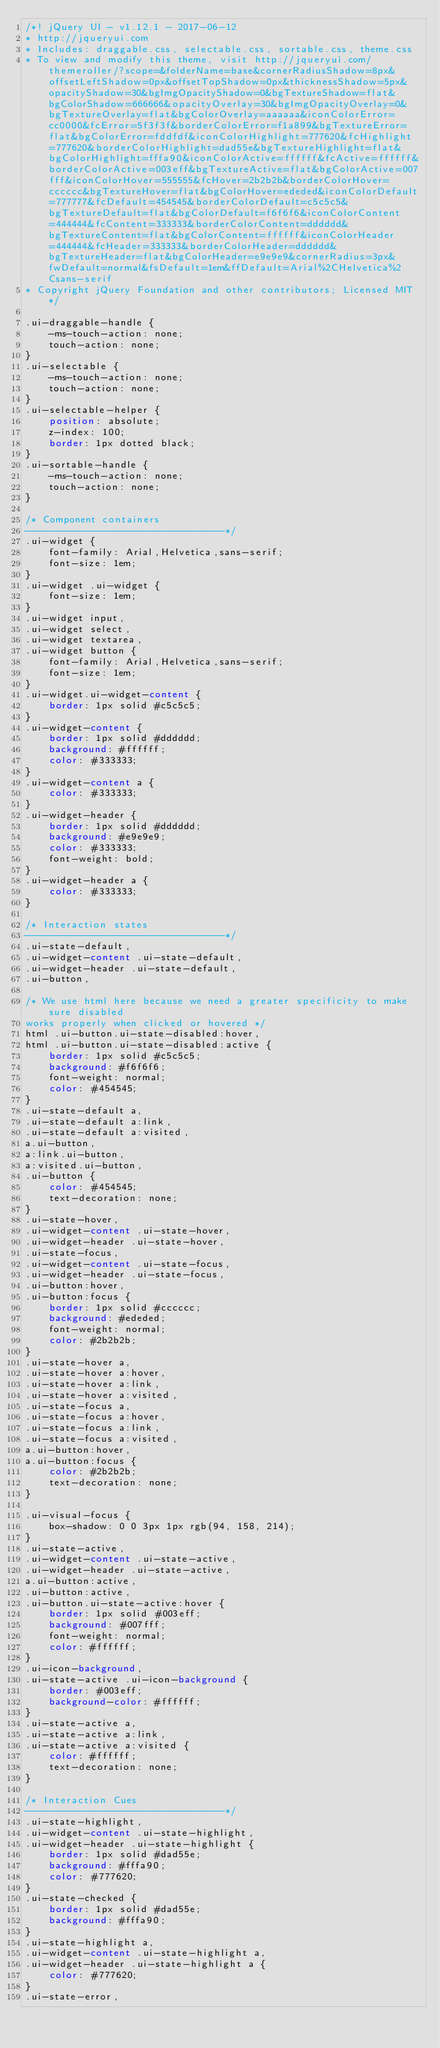<code> <loc_0><loc_0><loc_500><loc_500><_CSS_>/*! jQuery UI - v1.12.1 - 2017-06-12
* http://jqueryui.com
* Includes: draggable.css, selectable.css, sortable.css, theme.css
* To view and modify this theme, visit http://jqueryui.com/themeroller/?scope=&folderName=base&cornerRadiusShadow=8px&offsetLeftShadow=0px&offsetTopShadow=0px&thicknessShadow=5px&opacityShadow=30&bgImgOpacityShadow=0&bgTextureShadow=flat&bgColorShadow=666666&opacityOverlay=30&bgImgOpacityOverlay=0&bgTextureOverlay=flat&bgColorOverlay=aaaaaa&iconColorError=cc0000&fcError=5f3f3f&borderColorError=f1a899&bgTextureError=flat&bgColorError=fddfdf&iconColorHighlight=777620&fcHighlight=777620&borderColorHighlight=dad55e&bgTextureHighlight=flat&bgColorHighlight=fffa90&iconColorActive=ffffff&fcActive=ffffff&borderColorActive=003eff&bgTextureActive=flat&bgColorActive=007fff&iconColorHover=555555&fcHover=2b2b2b&borderColorHover=cccccc&bgTextureHover=flat&bgColorHover=ededed&iconColorDefault=777777&fcDefault=454545&borderColorDefault=c5c5c5&bgTextureDefault=flat&bgColorDefault=f6f6f6&iconColorContent=444444&fcContent=333333&borderColorContent=dddddd&bgTextureContent=flat&bgColorContent=ffffff&iconColorHeader=444444&fcHeader=333333&borderColorHeader=dddddd&bgTextureHeader=flat&bgColorHeader=e9e9e9&cornerRadius=3px&fwDefault=normal&fsDefault=1em&ffDefault=Arial%2CHelvetica%2Csans-serif
* Copyright jQuery Foundation and other contributors; Licensed MIT */

.ui-draggable-handle {
	-ms-touch-action: none;
	touch-action: none;
}
.ui-selectable {
	-ms-touch-action: none;
	touch-action: none;
}
.ui-selectable-helper {
	position: absolute;
	z-index: 100;
	border: 1px dotted black;
}
.ui-sortable-handle {
	-ms-touch-action: none;
	touch-action: none;
}

/* Component containers
----------------------------------*/
.ui-widget {
	font-family: Arial,Helvetica,sans-serif;
	font-size: 1em;
}
.ui-widget .ui-widget {
	font-size: 1em;
}
.ui-widget input,
.ui-widget select,
.ui-widget textarea,
.ui-widget button {
	font-family: Arial,Helvetica,sans-serif;
	font-size: 1em;
}
.ui-widget.ui-widget-content {
	border: 1px solid #c5c5c5;
}
.ui-widget-content {
	border: 1px solid #dddddd;
	background: #ffffff;
	color: #333333;
}
.ui-widget-content a {
	color: #333333;
}
.ui-widget-header {
	border: 1px solid #dddddd;
	background: #e9e9e9;
	color: #333333;
	font-weight: bold;
}
.ui-widget-header a {
	color: #333333;
}

/* Interaction states
----------------------------------*/
.ui-state-default,
.ui-widget-content .ui-state-default,
.ui-widget-header .ui-state-default,
.ui-button,

/* We use html here because we need a greater specificity to make sure disabled
works properly when clicked or hovered */
html .ui-button.ui-state-disabled:hover,
html .ui-button.ui-state-disabled:active {
	border: 1px solid #c5c5c5;
	background: #f6f6f6;
	font-weight: normal;
	color: #454545;
}
.ui-state-default a,
.ui-state-default a:link,
.ui-state-default a:visited,
a.ui-button,
a:link.ui-button,
a:visited.ui-button,
.ui-button {
	color: #454545;
	text-decoration: none;
}
.ui-state-hover,
.ui-widget-content .ui-state-hover,
.ui-widget-header .ui-state-hover,
.ui-state-focus,
.ui-widget-content .ui-state-focus,
.ui-widget-header .ui-state-focus,
.ui-button:hover,
.ui-button:focus {
	border: 1px solid #cccccc;
	background: #ededed;
	font-weight: normal;
	color: #2b2b2b;
}
.ui-state-hover a,
.ui-state-hover a:hover,
.ui-state-hover a:link,
.ui-state-hover a:visited,
.ui-state-focus a,
.ui-state-focus a:hover,
.ui-state-focus a:link,
.ui-state-focus a:visited,
a.ui-button:hover,
a.ui-button:focus {
	color: #2b2b2b;
	text-decoration: none;
}

.ui-visual-focus {
	box-shadow: 0 0 3px 1px rgb(94, 158, 214);
}
.ui-state-active,
.ui-widget-content .ui-state-active,
.ui-widget-header .ui-state-active,
a.ui-button:active,
.ui-button:active,
.ui-button.ui-state-active:hover {
	border: 1px solid #003eff;
	background: #007fff;
	font-weight: normal;
	color: #ffffff;
}
.ui-icon-background,
.ui-state-active .ui-icon-background {
	border: #003eff;
	background-color: #ffffff;
}
.ui-state-active a,
.ui-state-active a:link,
.ui-state-active a:visited {
	color: #ffffff;
	text-decoration: none;
}

/* Interaction Cues
----------------------------------*/
.ui-state-highlight,
.ui-widget-content .ui-state-highlight,
.ui-widget-header .ui-state-highlight {
	border: 1px solid #dad55e;
	background: #fffa90;
	color: #777620;
}
.ui-state-checked {
	border: 1px solid #dad55e;
	background: #fffa90;
}
.ui-state-highlight a,
.ui-widget-content .ui-state-highlight a,
.ui-widget-header .ui-state-highlight a {
	color: #777620;
}
.ui-state-error,</code> 